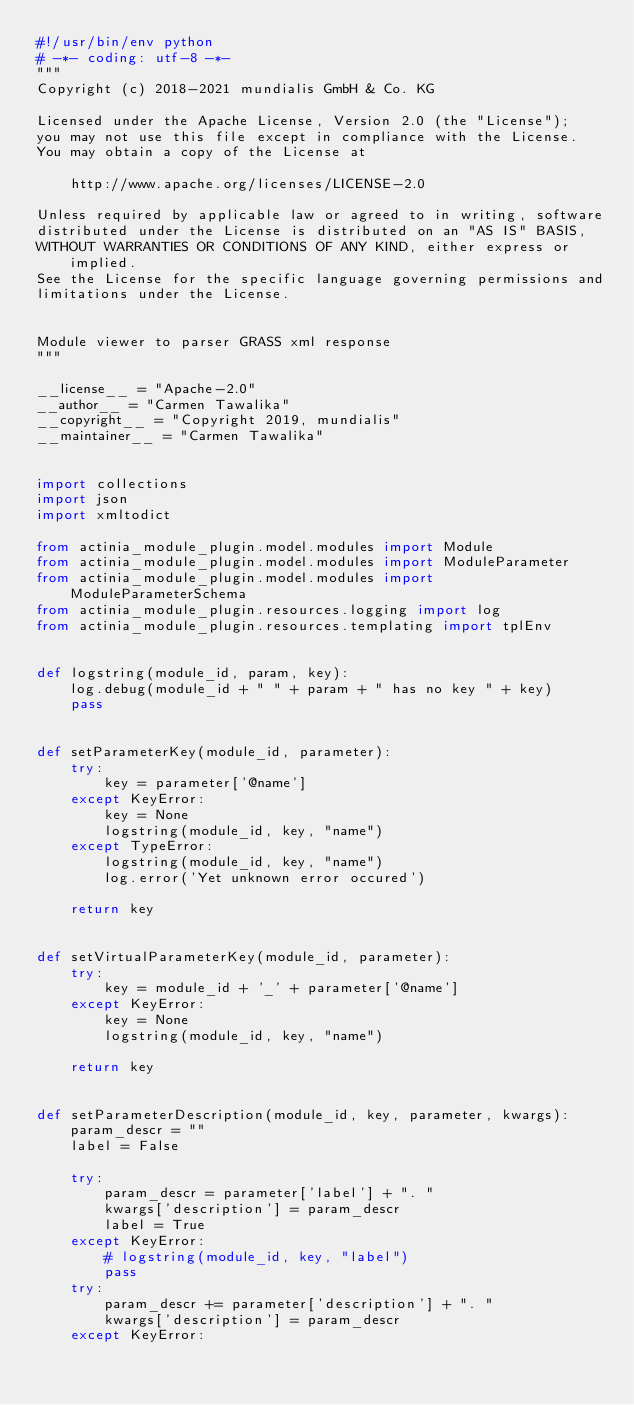<code> <loc_0><loc_0><loc_500><loc_500><_Python_>#!/usr/bin/env python
# -*- coding: utf-8 -*-
"""
Copyright (c) 2018-2021 mundialis GmbH & Co. KG

Licensed under the Apache License, Version 2.0 (the "License");
you may not use this file except in compliance with the License.
You may obtain a copy of the License at

    http://www.apache.org/licenses/LICENSE-2.0

Unless required by applicable law or agreed to in writing, software
distributed under the License is distributed on an "AS IS" BASIS,
WITHOUT WARRANTIES OR CONDITIONS OF ANY KIND, either express or implied.
See the License for the specific language governing permissions and
limitations under the License.


Module viewer to parser GRASS xml response
"""

__license__ = "Apache-2.0"
__author__ = "Carmen Tawalika"
__copyright__ = "Copyright 2019, mundialis"
__maintainer__ = "Carmen Tawalika"


import collections
import json
import xmltodict

from actinia_module_plugin.model.modules import Module
from actinia_module_plugin.model.modules import ModuleParameter
from actinia_module_plugin.model.modules import ModuleParameterSchema
from actinia_module_plugin.resources.logging import log
from actinia_module_plugin.resources.templating import tplEnv


def logstring(module_id, param, key):
    log.debug(module_id + " " + param + " has no key " + key)
    pass


def setParameterKey(module_id, parameter):
    try:
        key = parameter['@name']
    except KeyError:
        key = None
        logstring(module_id, key, "name")
    except TypeError:
        logstring(module_id, key, "name")
        log.error('Yet unknown error occured')

    return key


def setVirtualParameterKey(module_id, parameter):
    try:
        key = module_id + '_' + parameter['@name']
    except KeyError:
        key = None
        logstring(module_id, key, "name")

    return key


def setParameterDescription(module_id, key, parameter, kwargs):
    param_descr = ""
    label = False

    try:
        param_descr = parameter['label'] + ". "
        kwargs['description'] = param_descr
        label = True
    except KeyError:
        # logstring(module_id, key, "label")
        pass
    try:
        param_descr += parameter['description'] + ". "
        kwargs['description'] = param_descr
    except KeyError:</code> 